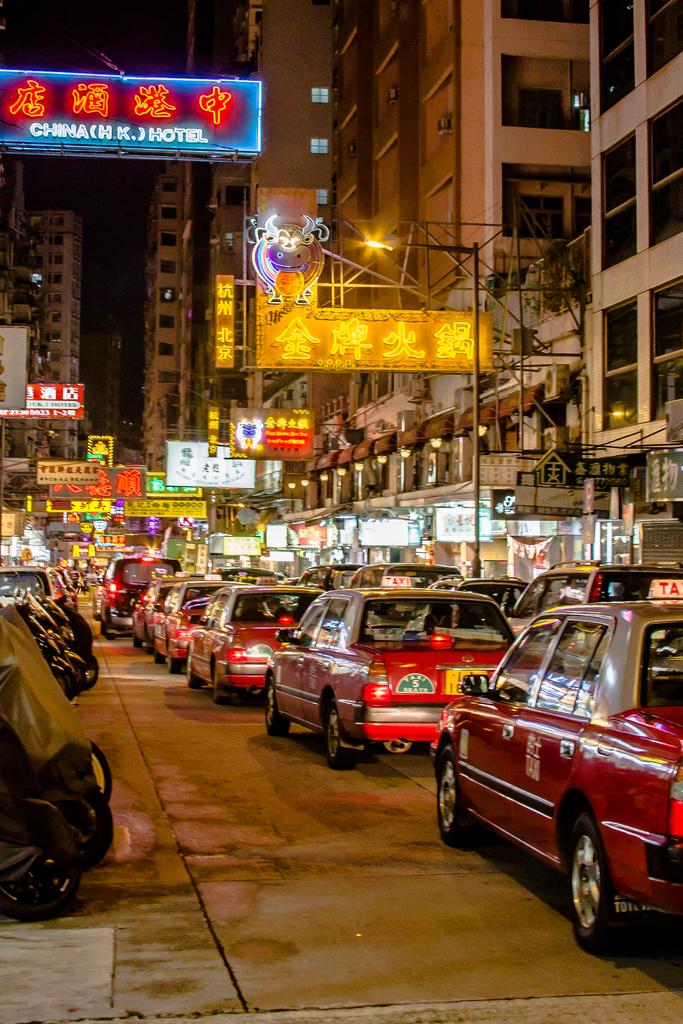What's the name of this hotel?
Your answer should be very brief. Chimachi. 